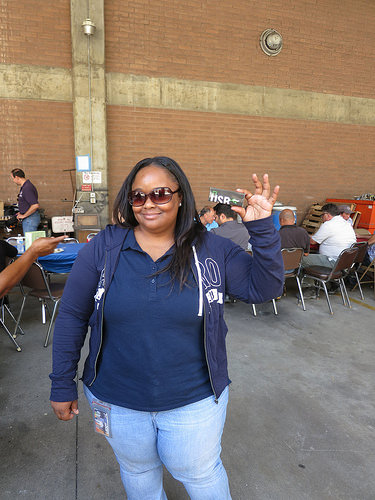<image>
Can you confirm if the board is on the wall? No. The board is not positioned on the wall. They may be near each other, but the board is not supported by or resting on top of the wall. 